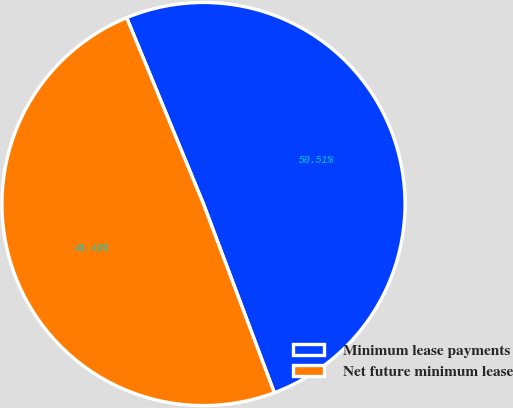<chart> <loc_0><loc_0><loc_500><loc_500><pie_chart><fcel>Minimum lease payments<fcel>Net future minimum lease<nl><fcel>50.51%<fcel>49.49%<nl></chart> 